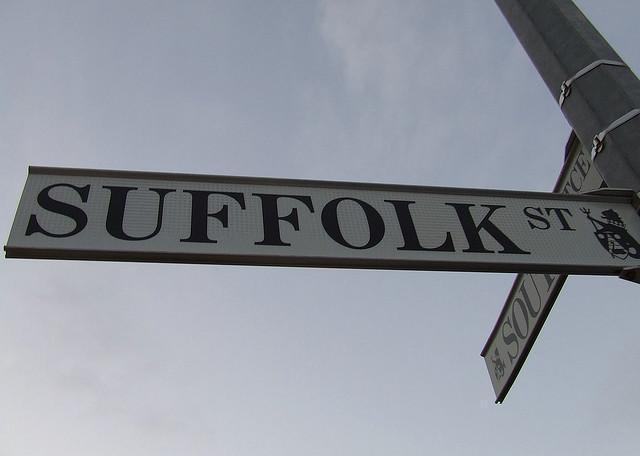How many signs are on the post?
Give a very brief answer. 2. 